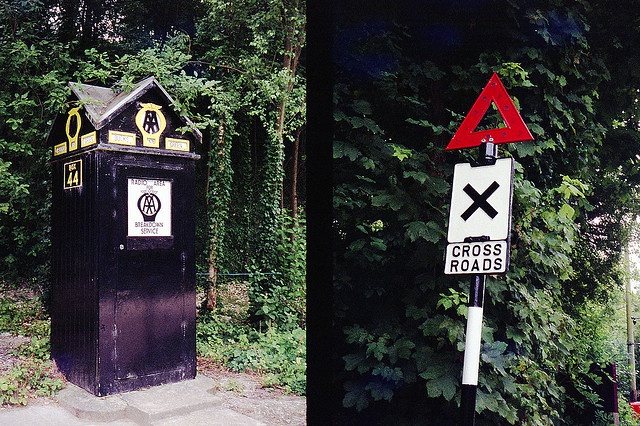Describe the objects in this image and their specific colors. I can see various objects in this image with different colors. 